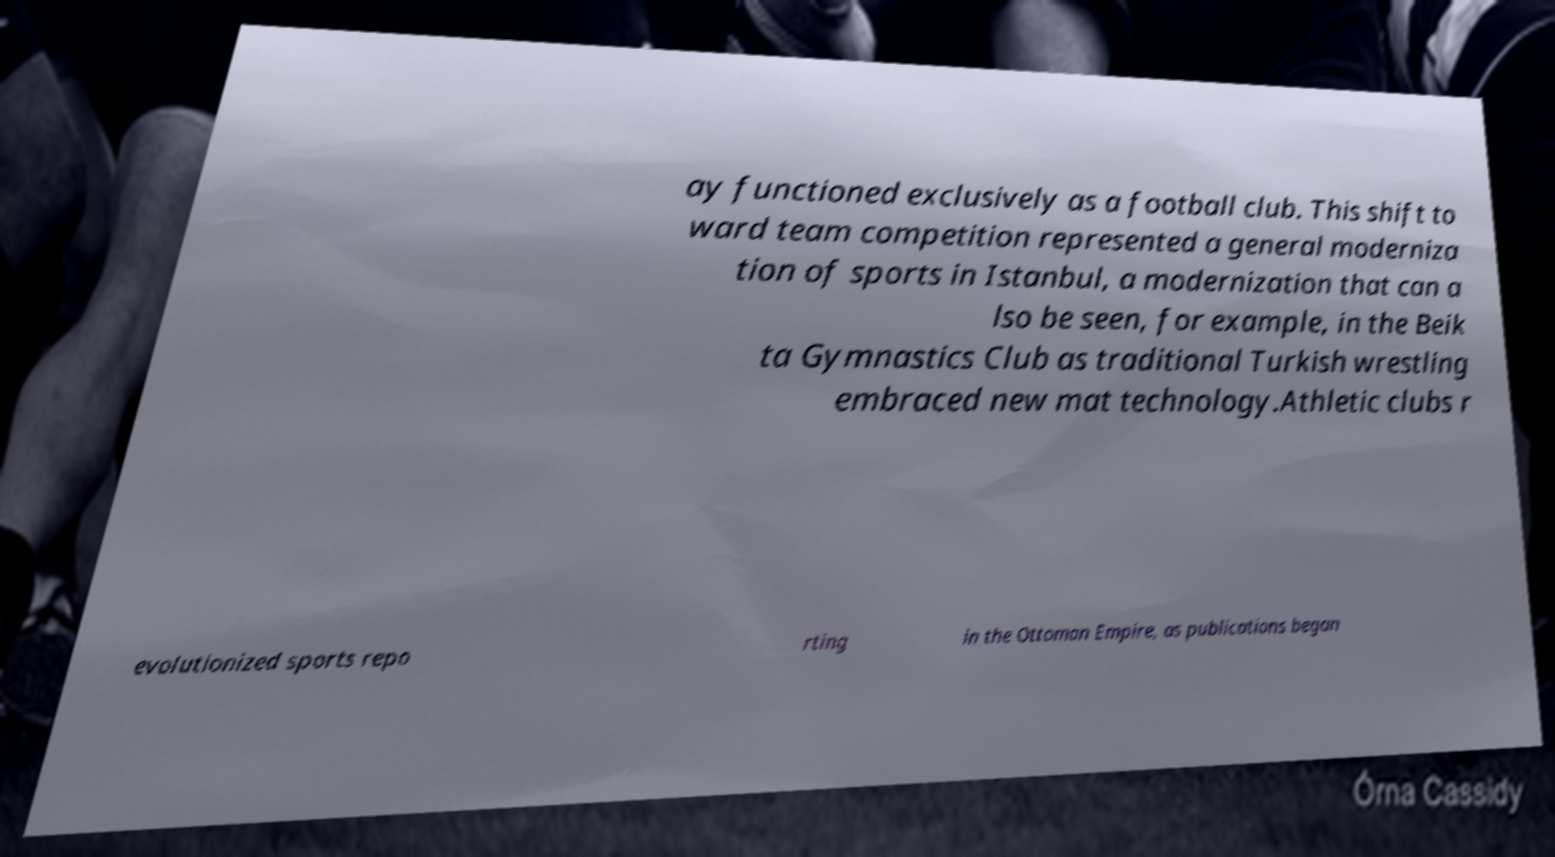Could you extract and type out the text from this image? ay functioned exclusively as a football club. This shift to ward team competition represented a general moderniza tion of sports in Istanbul, a modernization that can a lso be seen, for example, in the Beik ta Gymnastics Club as traditional Turkish wrestling embraced new mat technology.Athletic clubs r evolutionized sports repo rting in the Ottoman Empire, as publications began 